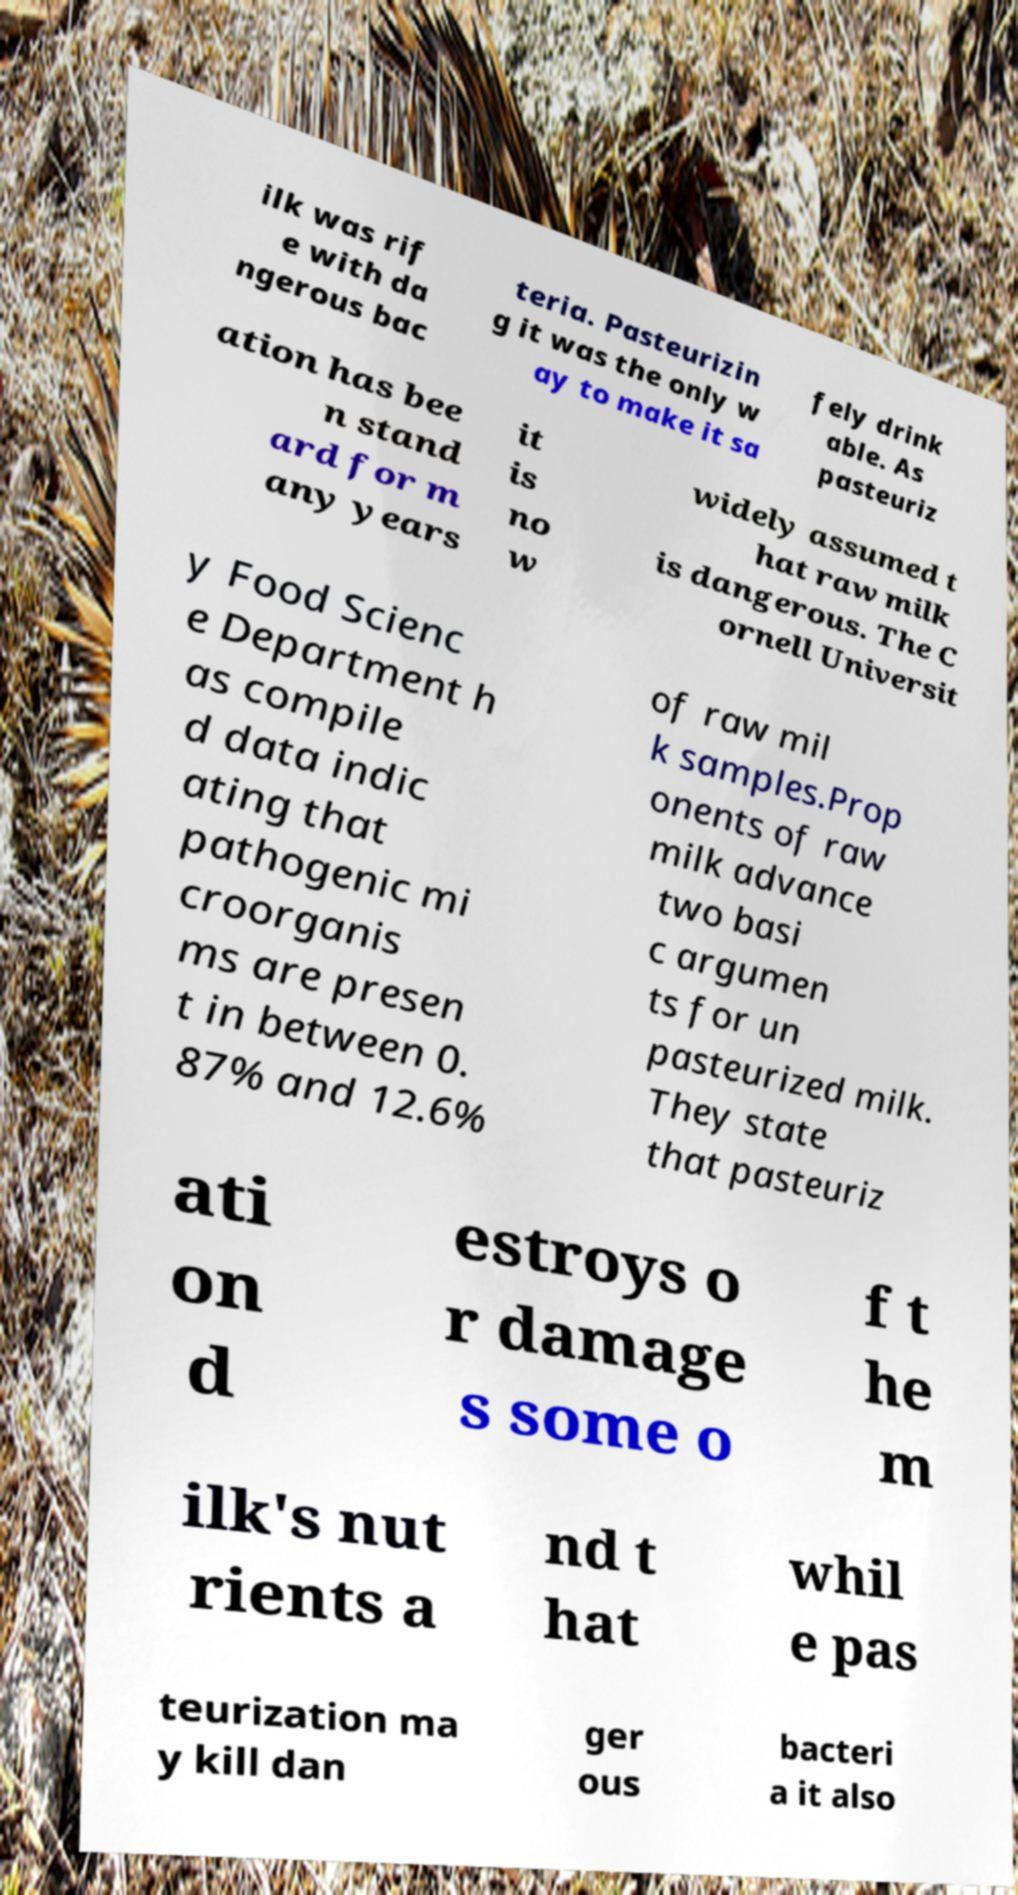I need the written content from this picture converted into text. Can you do that? ilk was rif e with da ngerous bac teria. Pasteurizin g it was the only w ay to make it sa fely drink able. As pasteuriz ation has bee n stand ard for m any years it is no w widely assumed t hat raw milk is dangerous. The C ornell Universit y Food Scienc e Department h as compile d data indic ating that pathogenic mi croorganis ms are presen t in between 0. 87% and 12.6% of raw mil k samples.Prop onents of raw milk advance two basi c argumen ts for un pasteurized milk. They state that pasteuriz ati on d estroys o r damage s some o f t he m ilk's nut rients a nd t hat whil e pas teurization ma y kill dan ger ous bacteri a it also 